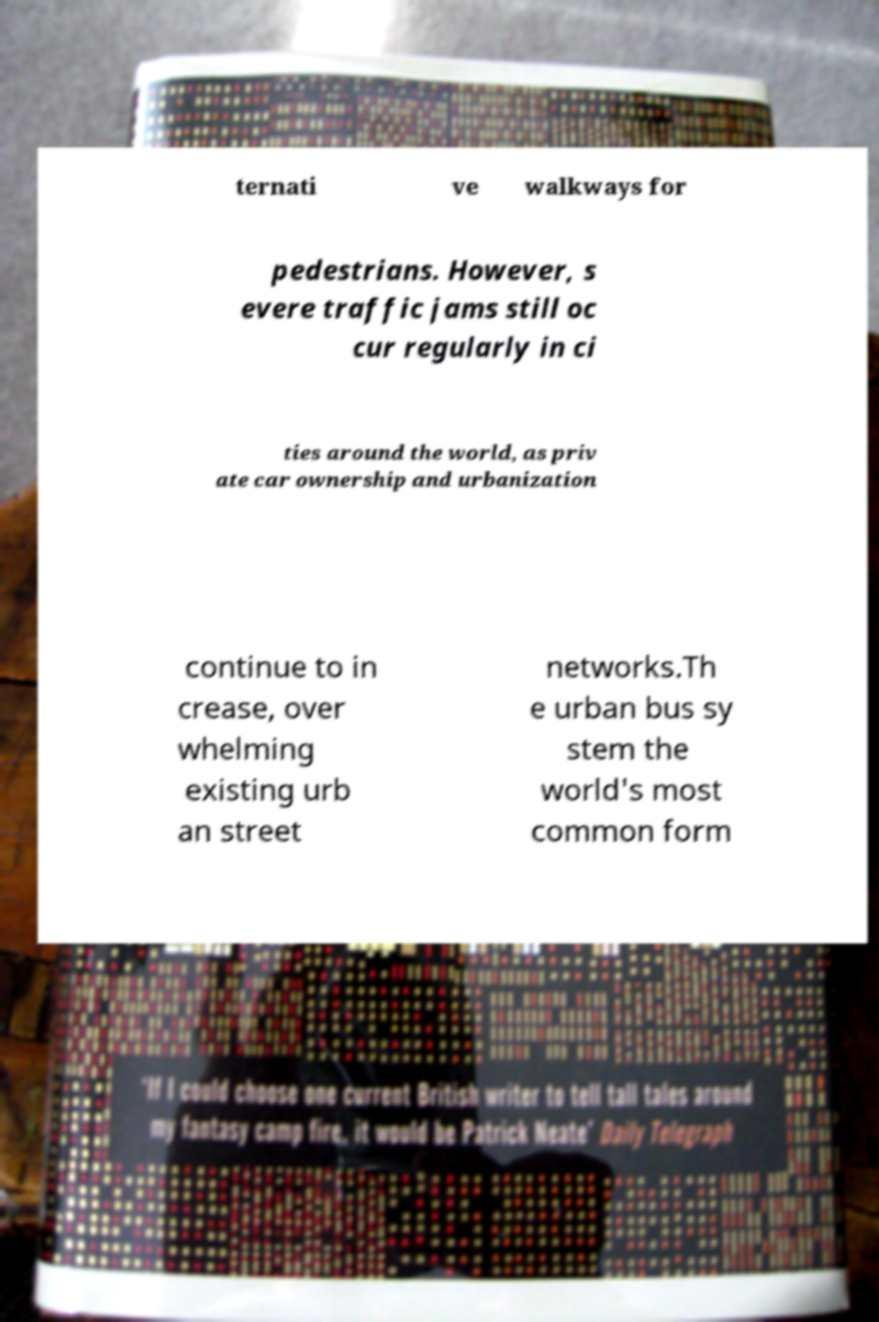Could you assist in decoding the text presented in this image and type it out clearly? ternati ve walkways for pedestrians. However, s evere traffic jams still oc cur regularly in ci ties around the world, as priv ate car ownership and urbanization continue to in crease, over whelming existing urb an street networks.Th e urban bus sy stem the world's most common form 